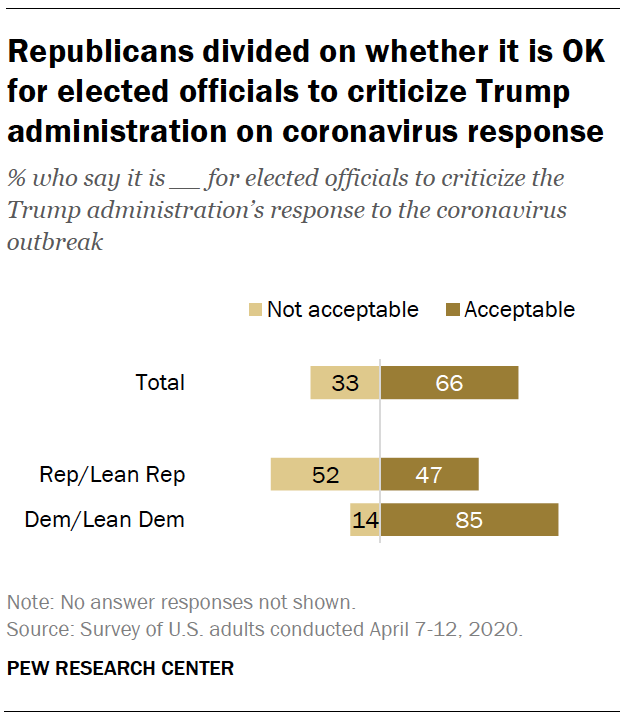List a handful of essential elements in this visual. What is the acceptable value for bar in the total? 0.043055556, the ratio of Not acceptable and Acceptable in total, is approximately 0.043055556. 